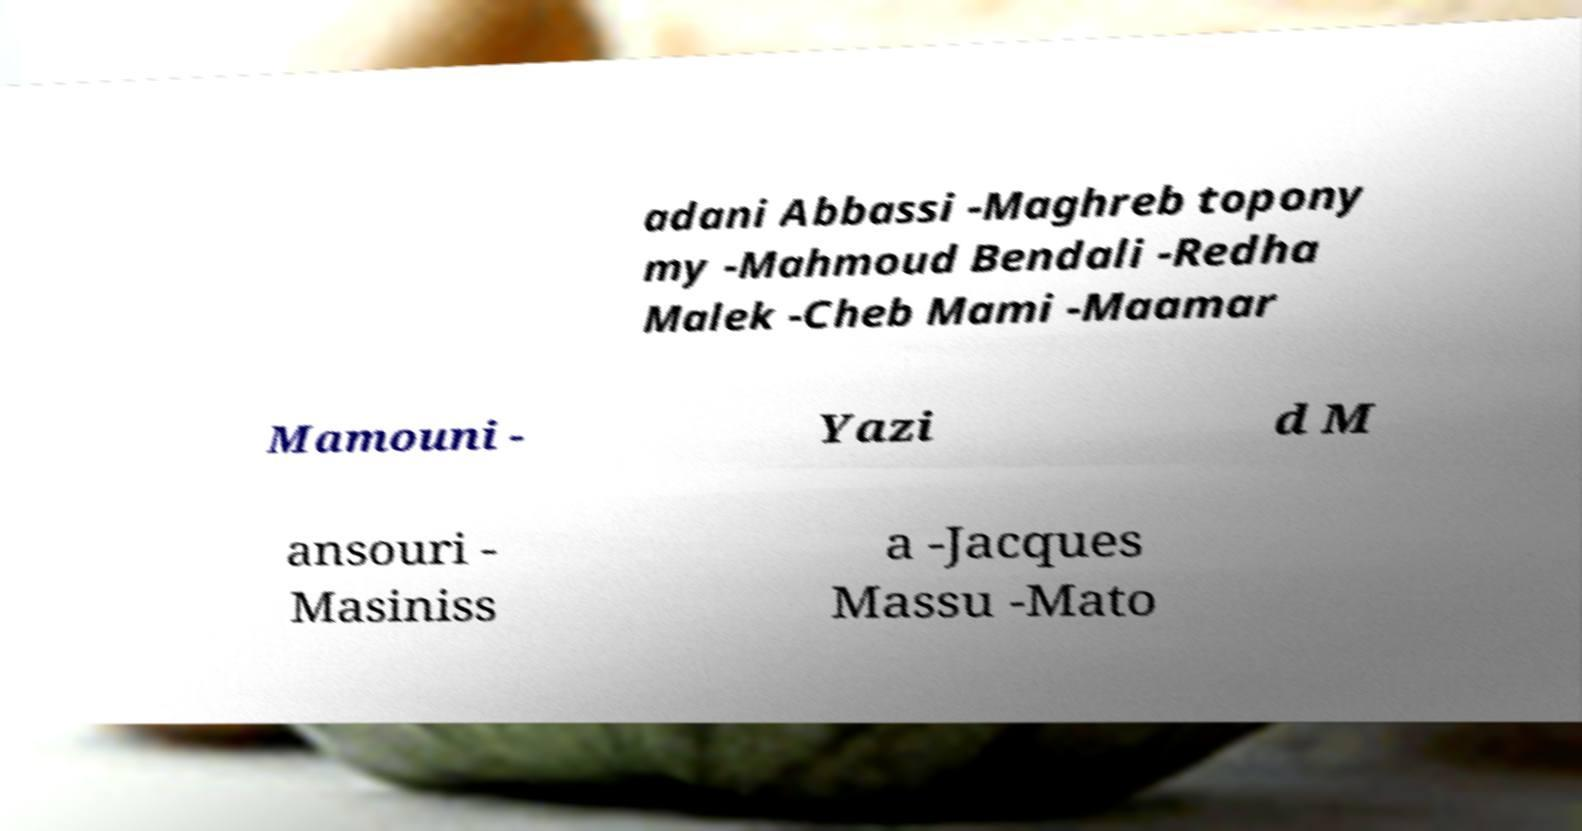I need the written content from this picture converted into text. Can you do that? adani Abbassi -Maghreb topony my -Mahmoud Bendali -Redha Malek -Cheb Mami -Maamar Mamouni - Yazi d M ansouri - Masiniss a -Jacques Massu -Mato 